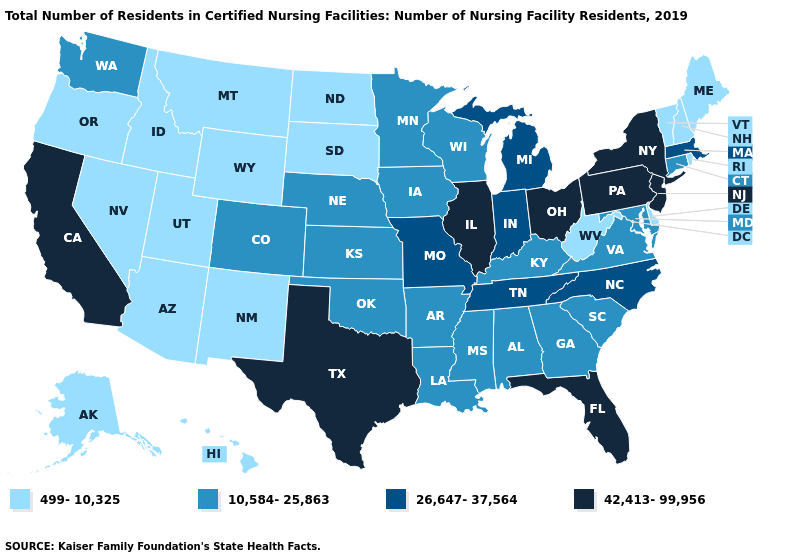Does California have the highest value in the West?
Quick response, please. Yes. Name the states that have a value in the range 499-10,325?
Give a very brief answer. Alaska, Arizona, Delaware, Hawaii, Idaho, Maine, Montana, Nevada, New Hampshire, New Mexico, North Dakota, Oregon, Rhode Island, South Dakota, Utah, Vermont, West Virginia, Wyoming. Does West Virginia have the lowest value in the South?
Concise answer only. Yes. What is the lowest value in the USA?
Answer briefly. 499-10,325. Name the states that have a value in the range 10,584-25,863?
Quick response, please. Alabama, Arkansas, Colorado, Connecticut, Georgia, Iowa, Kansas, Kentucky, Louisiana, Maryland, Minnesota, Mississippi, Nebraska, Oklahoma, South Carolina, Virginia, Washington, Wisconsin. Which states have the lowest value in the South?
Quick response, please. Delaware, West Virginia. Which states have the lowest value in the USA?
Be succinct. Alaska, Arizona, Delaware, Hawaii, Idaho, Maine, Montana, Nevada, New Hampshire, New Mexico, North Dakota, Oregon, Rhode Island, South Dakota, Utah, Vermont, West Virginia, Wyoming. Name the states that have a value in the range 42,413-99,956?
Keep it brief. California, Florida, Illinois, New Jersey, New York, Ohio, Pennsylvania, Texas. Which states have the lowest value in the South?
Keep it brief. Delaware, West Virginia. Among the states that border Maryland , which have the lowest value?
Be succinct. Delaware, West Virginia. Does Nebraska have the lowest value in the USA?
Keep it brief. No. Does Florida have a higher value than New Hampshire?
Short answer required. Yes. Which states have the highest value in the USA?
Give a very brief answer. California, Florida, Illinois, New Jersey, New York, Ohio, Pennsylvania, Texas. What is the lowest value in the USA?
Concise answer only. 499-10,325. Among the states that border Massachusetts , which have the lowest value?
Write a very short answer. New Hampshire, Rhode Island, Vermont. 